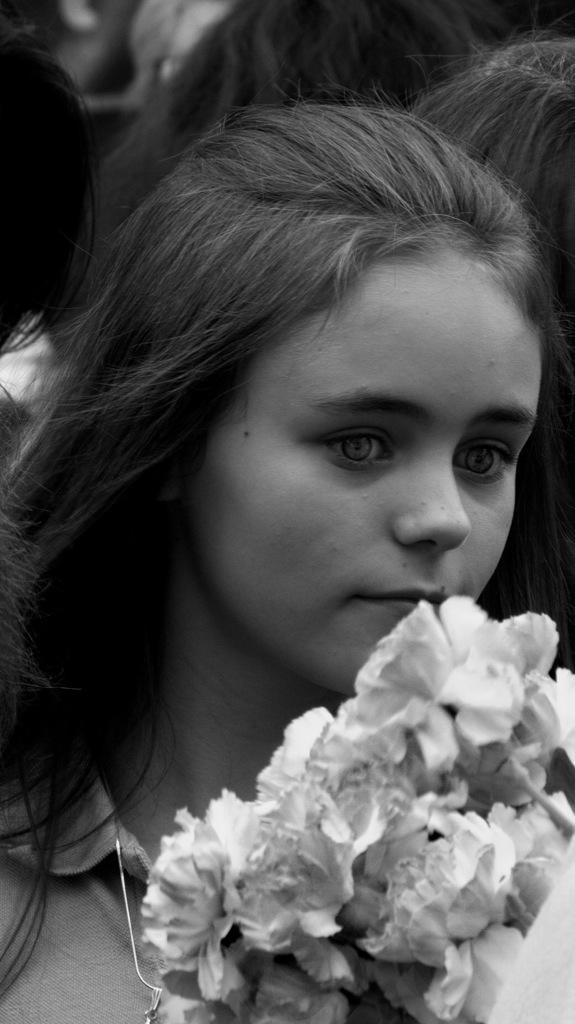How would you summarize this image in a sentence or two? In this picture I can observe a girl. This is a black and white image. In front of the woman it is looking like a bouquet. 